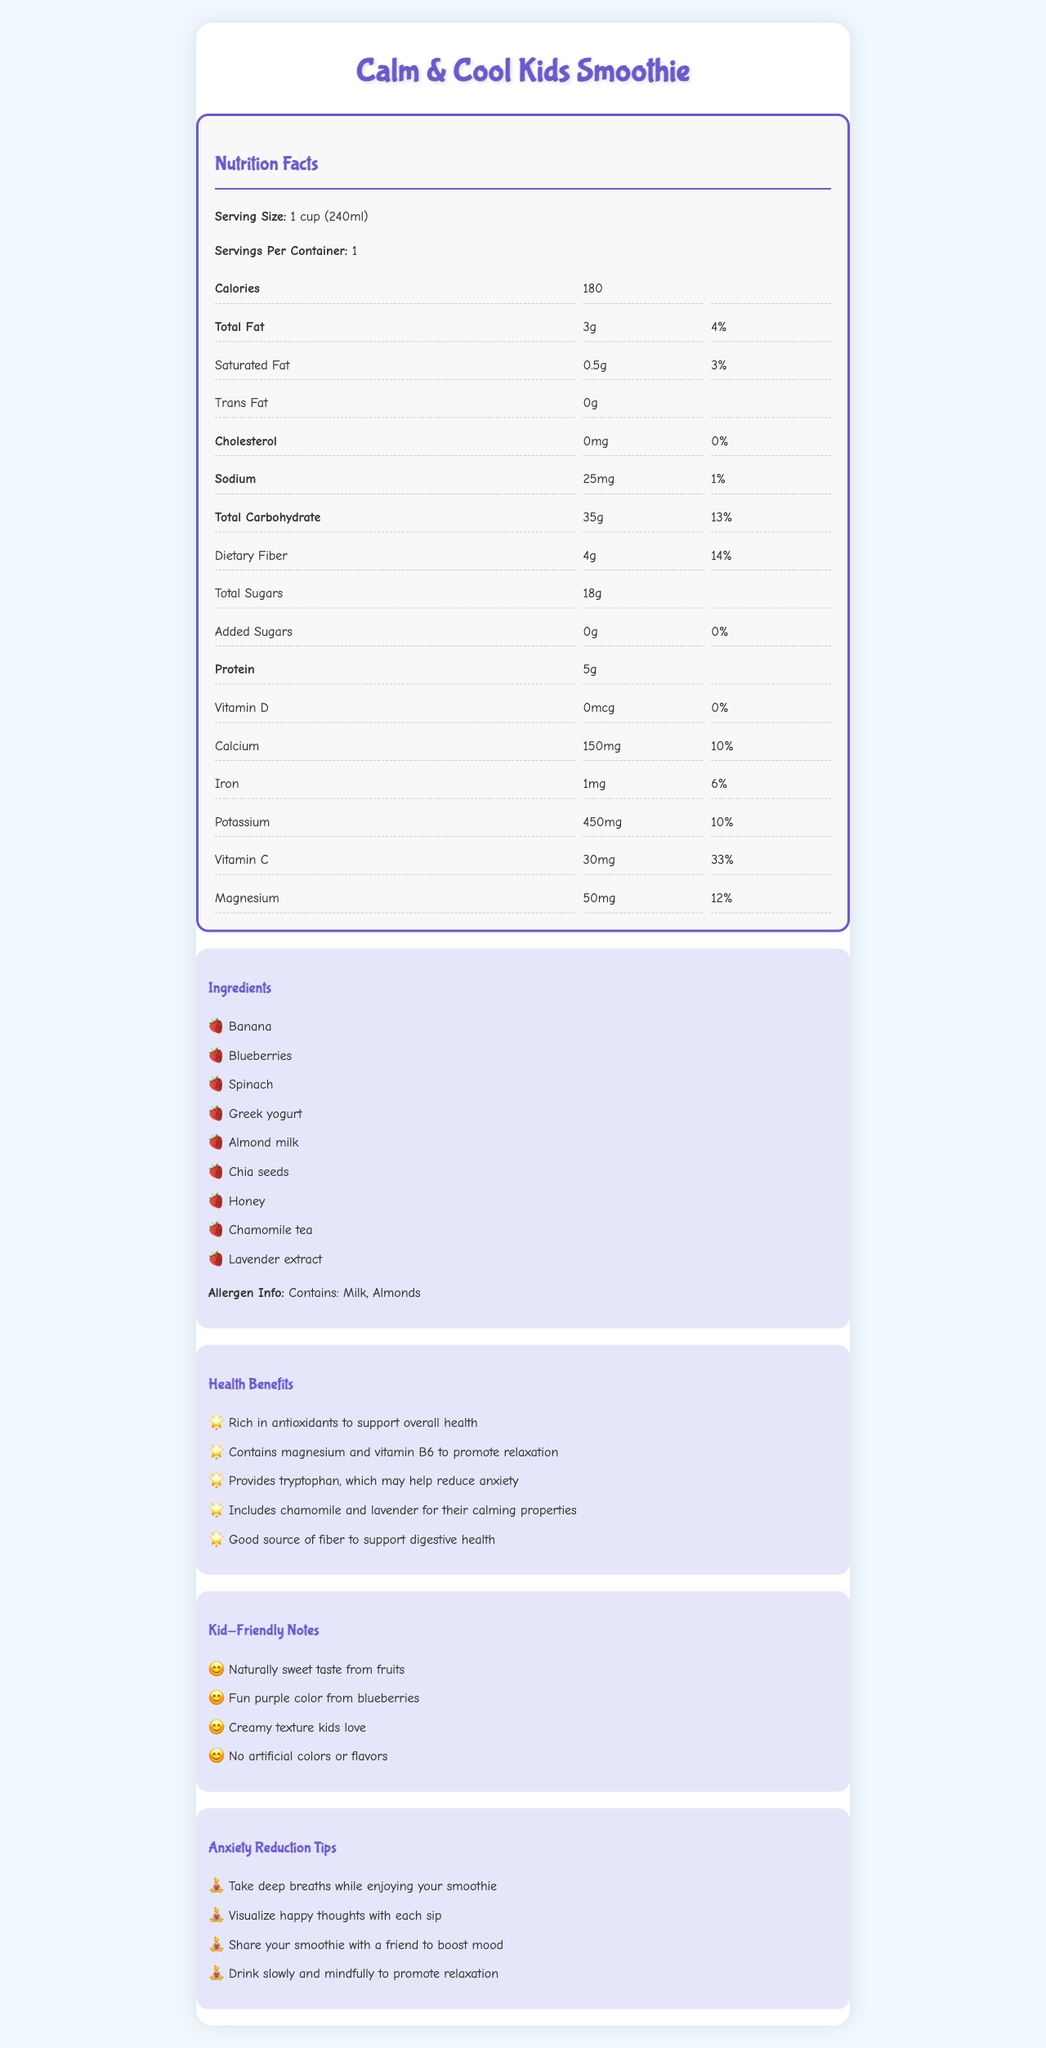what is the product name? The document title and heading clearly state that the product name is Calm & Cool Kids Smoothie.
Answer: Calm & Cool Kids Smoothie what is the serving size? The document includes a section that lists the serving size as 1 cup (240ml).
Answer: 1 cup (240ml) how many calories are in one serving? Under the "Nutrition Facts" section, it states that there are 180 calories per serving.
Answer: 180 calories how much protein does this smoothie have? The "Nutrition Facts" section lists the amount of protein in one serving as 5g.
Answer: 5g what vitamins and minerals does this smoothie contain? The "Nutrition Facts" section provides amounts for Vitamin D, Calcium, Iron, Potassium, Vitamin C, and Magnesium, indicating that these are present in the smoothie.
Answer: Vitamin D, Calcium, Iron, Potassium, Vitamin C, Magnesium which of these ingredients is not in the smoothie? A. Blueberries B. Spinach C. Strawberries D. Greek yogurt The "Ingredients" section lists Banana, Blueberries, Spinach, Greek yogurt, Almond milk, Chia seeds, Honey, Chamomile tea, and Lavender extract, but does not list Strawberries.
Answer: C. Strawberries which health benefit is specifically related to anxiety reduction? A. Rich in antioxidants B. Contains magnesium and vitamin B6 C. Provides tryptophan D. Includes chamomile and lavender The "Health Benefits" section lists "Includes chamomile and lavender for their calming properties," which is particularly relevant to anxiety reduction.
Answer: D. Includes chamomile and lavender is there any added sugar in this smoothie? The "Nutrition Facts" section indicates "Added Sugars: 0g", meaning there is no added sugar in this smoothie.
Answer: No is this smoothie kid-friendly? The document includes a "Kid-Friendly Notes" section that highlights the naturally sweet taste, fun purple color, creamy texture, and absence of artificial colors or flavors, making it kid-friendly.
Answer: Yes how can you use the smoothie to help reduce anxiety? The "Anxiety Reduction Tips" section provides these specific methods for reducing anxiety with the smoothie.
Answer: Take deep breaths, visualize happy thoughts, share with a friend, drink slowly and mindfully who is the target audience for this document? A. Kids with anxiety B. Adults on a diet C. Fitness enthusiasts D. People with diabetes The document is crafted to address the needs and interests of kids, especially those struggling with anxiety, as evidenced by the product name and specific sections addressing anxiety reduction.
Answer: A. Kids with anxiety what are two ingredients in the smoothie? The "Ingredients" section lists Banana and Blueberries among other ingredients.
Answer: Banana, Blueberries summarize the main idea of the document. This summary encapsulates the purpose of the document, which is to provide comprehensive details about the Calm & Cool Kids Smoothie, including nutrition, ingredients, health benefits, kid-friendly aspects, and anxiety reduction tips.
Answer: The document provides nutritional information, ingredient details, health benefits, and tips for anxiety reduction for the Calm & Cool Kids Smoothie, which is designed to help children with anxiety. what color is associated with the heading and key sections in the document? The document uses a light purple (lavender) color for headings and key sections, creating a calm and kid-friendly visual aesthetic.
Answer: Light purple (Lavender) what flavors are included in the kid-friendly notes? The "Kid-Friendly Notes" section mentions the naturally sweet taste from the fruits included in the smoothie.
Answer: Naturally sweet from fruits what is the total percentage of daily value for dietary fiber? Under the "Nutrition Facts" section, it states that the dietary fiber provides 14% of the daily value.
Answer: 14% what type of milk is used in the smoothie? The "Ingredients" section lists Almond milk as one of the ingredients.
Answer: Almond milk does the document mention any lactose? There is no specific mention of lactose in the document. The document only mentions "Milk" in the allergen info section due to the presence of Greek yogurt, which may contain lactose, but the term “lactose” is not explicitly mentioned.
Answer: No 